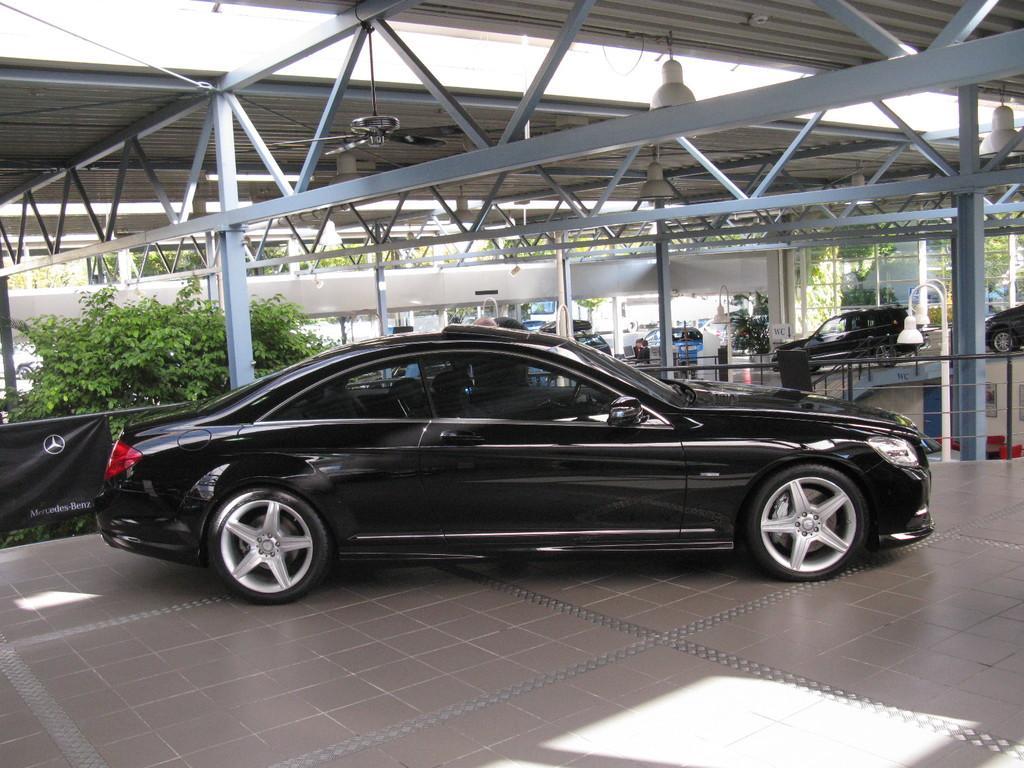Please provide a concise description of this image. In the image there is a black car on the land under a shelter, behind it there is a plant and many cars in the background, this seems to be in a car service center. 